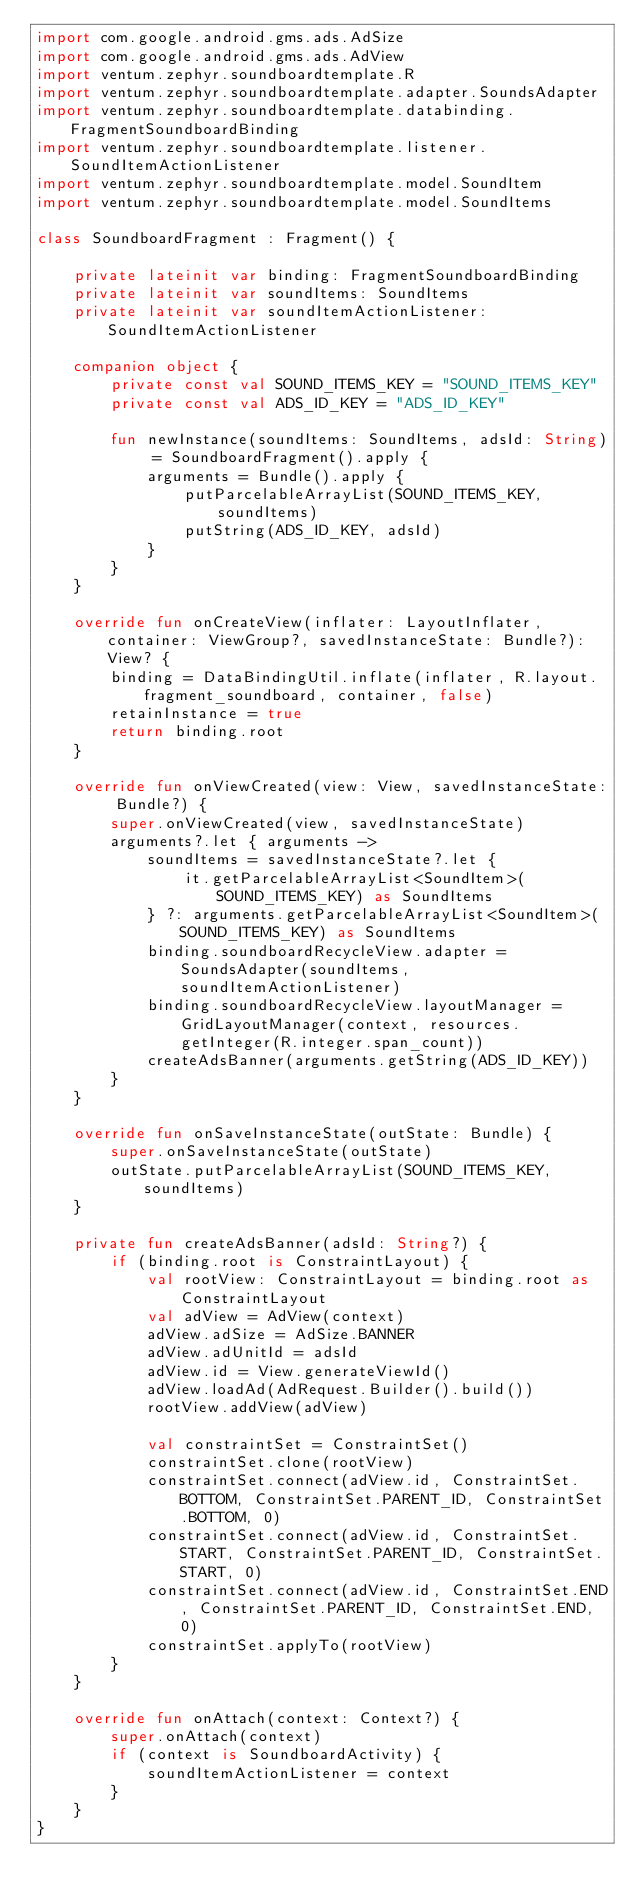<code> <loc_0><loc_0><loc_500><loc_500><_Kotlin_>import com.google.android.gms.ads.AdSize
import com.google.android.gms.ads.AdView
import ventum.zephyr.soundboardtemplate.R
import ventum.zephyr.soundboardtemplate.adapter.SoundsAdapter
import ventum.zephyr.soundboardtemplate.databinding.FragmentSoundboardBinding
import ventum.zephyr.soundboardtemplate.listener.SoundItemActionListener
import ventum.zephyr.soundboardtemplate.model.SoundItem
import ventum.zephyr.soundboardtemplate.model.SoundItems

class SoundboardFragment : Fragment() {

    private lateinit var binding: FragmentSoundboardBinding
    private lateinit var soundItems: SoundItems
    private lateinit var soundItemActionListener: SoundItemActionListener

    companion object {
        private const val SOUND_ITEMS_KEY = "SOUND_ITEMS_KEY"
        private const val ADS_ID_KEY = "ADS_ID_KEY"

        fun newInstance(soundItems: SoundItems, adsId: String) = SoundboardFragment().apply {
            arguments = Bundle().apply {
                putParcelableArrayList(SOUND_ITEMS_KEY, soundItems)
                putString(ADS_ID_KEY, adsId)
            }
        }
    }

    override fun onCreateView(inflater: LayoutInflater, container: ViewGroup?, savedInstanceState: Bundle?): View? {
        binding = DataBindingUtil.inflate(inflater, R.layout.fragment_soundboard, container, false)
        retainInstance = true
        return binding.root
    }

    override fun onViewCreated(view: View, savedInstanceState: Bundle?) {
        super.onViewCreated(view, savedInstanceState)
        arguments?.let { arguments ->
            soundItems = savedInstanceState?.let {
                it.getParcelableArrayList<SoundItem>(SOUND_ITEMS_KEY) as SoundItems
            } ?: arguments.getParcelableArrayList<SoundItem>(SOUND_ITEMS_KEY) as SoundItems
            binding.soundboardRecycleView.adapter = SoundsAdapter(soundItems, soundItemActionListener)
            binding.soundboardRecycleView.layoutManager = GridLayoutManager(context, resources.getInteger(R.integer.span_count))
            createAdsBanner(arguments.getString(ADS_ID_KEY))
        }
    }

    override fun onSaveInstanceState(outState: Bundle) {
        super.onSaveInstanceState(outState)
        outState.putParcelableArrayList(SOUND_ITEMS_KEY, soundItems)
    }

    private fun createAdsBanner(adsId: String?) {
        if (binding.root is ConstraintLayout) {
            val rootView: ConstraintLayout = binding.root as ConstraintLayout
            val adView = AdView(context)
            adView.adSize = AdSize.BANNER
            adView.adUnitId = adsId
            adView.id = View.generateViewId()
            adView.loadAd(AdRequest.Builder().build())
            rootView.addView(adView)

            val constraintSet = ConstraintSet()
            constraintSet.clone(rootView)
            constraintSet.connect(adView.id, ConstraintSet.BOTTOM, ConstraintSet.PARENT_ID, ConstraintSet.BOTTOM, 0)
            constraintSet.connect(adView.id, ConstraintSet.START, ConstraintSet.PARENT_ID, ConstraintSet.START, 0)
            constraintSet.connect(adView.id, ConstraintSet.END, ConstraintSet.PARENT_ID, ConstraintSet.END, 0)
            constraintSet.applyTo(rootView)
        }
    }

    override fun onAttach(context: Context?) {
        super.onAttach(context)
        if (context is SoundboardActivity) {
            soundItemActionListener = context
        }
    }
}</code> 